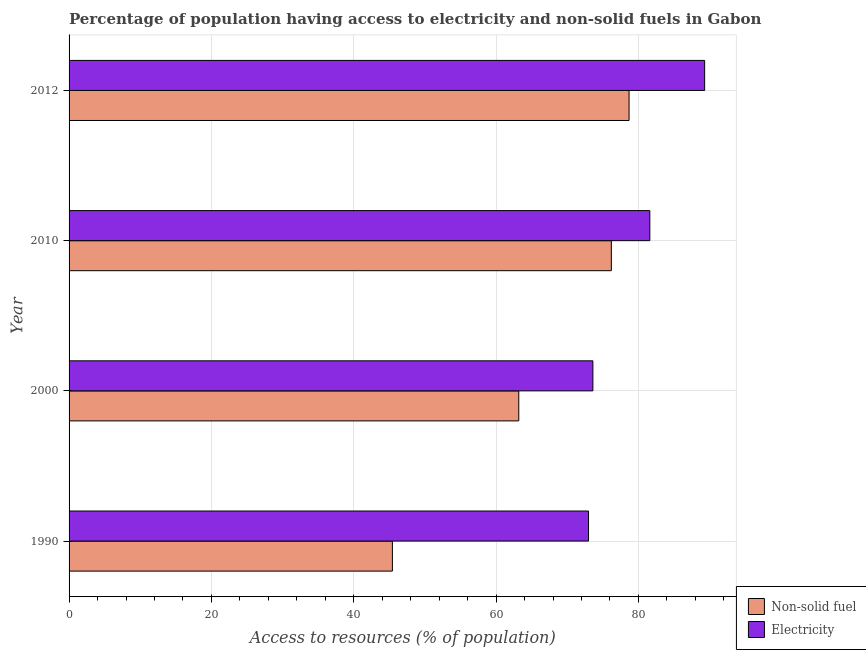How many different coloured bars are there?
Keep it short and to the point. 2. Are the number of bars per tick equal to the number of legend labels?
Give a very brief answer. Yes. Are the number of bars on each tick of the Y-axis equal?
Offer a very short reply. Yes. How many bars are there on the 1st tick from the top?
Offer a terse response. 2. In how many cases, is the number of bars for a given year not equal to the number of legend labels?
Your answer should be very brief. 0. What is the percentage of population having access to non-solid fuel in 2000?
Your answer should be very brief. 63.19. Across all years, what is the maximum percentage of population having access to electricity?
Make the answer very short. 89.3. Across all years, what is the minimum percentage of population having access to non-solid fuel?
Your answer should be compact. 45.43. In which year was the percentage of population having access to electricity minimum?
Your response must be concise. 1990. What is the total percentage of population having access to non-solid fuel in the graph?
Your answer should be very brief. 263.49. What is the difference between the percentage of population having access to non-solid fuel in 1990 and that in 2010?
Provide a succinct answer. -30.76. What is the difference between the percentage of population having access to non-solid fuel in 2000 and the percentage of population having access to electricity in 1990?
Keep it short and to the point. -9.8. What is the average percentage of population having access to electricity per year?
Provide a short and direct response. 79.37. In the year 2000, what is the difference between the percentage of population having access to non-solid fuel and percentage of population having access to electricity?
Ensure brevity in your answer.  -10.41. In how many years, is the percentage of population having access to electricity greater than 16 %?
Your answer should be very brief. 4. What is the ratio of the percentage of population having access to electricity in 1990 to that in 2000?
Offer a terse response. 0.99. Is the difference between the percentage of population having access to electricity in 2010 and 2012 greater than the difference between the percentage of population having access to non-solid fuel in 2010 and 2012?
Your response must be concise. No. What is the difference between the highest and the second highest percentage of population having access to electricity?
Provide a succinct answer. 7.7. What is the difference between the highest and the lowest percentage of population having access to electricity?
Offer a very short reply. 16.31. In how many years, is the percentage of population having access to electricity greater than the average percentage of population having access to electricity taken over all years?
Offer a very short reply. 2. What does the 2nd bar from the top in 2010 represents?
Your response must be concise. Non-solid fuel. What does the 2nd bar from the bottom in 2000 represents?
Provide a short and direct response. Electricity. Are all the bars in the graph horizontal?
Make the answer very short. Yes. How many years are there in the graph?
Offer a terse response. 4. What is the difference between two consecutive major ticks on the X-axis?
Keep it short and to the point. 20. Does the graph contain any zero values?
Your answer should be very brief. No. Does the graph contain grids?
Ensure brevity in your answer.  Yes. What is the title of the graph?
Make the answer very short. Percentage of population having access to electricity and non-solid fuels in Gabon. What is the label or title of the X-axis?
Provide a succinct answer. Access to resources (% of population). What is the label or title of the Y-axis?
Offer a terse response. Year. What is the Access to resources (% of population) of Non-solid fuel in 1990?
Keep it short and to the point. 45.43. What is the Access to resources (% of population) in Electricity in 1990?
Provide a succinct answer. 72.99. What is the Access to resources (% of population) of Non-solid fuel in 2000?
Provide a succinct answer. 63.19. What is the Access to resources (% of population) in Electricity in 2000?
Ensure brevity in your answer.  73.6. What is the Access to resources (% of population) of Non-solid fuel in 2010?
Offer a very short reply. 76.19. What is the Access to resources (% of population) of Electricity in 2010?
Give a very brief answer. 81.6. What is the Access to resources (% of population) in Non-solid fuel in 2012?
Provide a short and direct response. 78.68. What is the Access to resources (% of population) in Electricity in 2012?
Ensure brevity in your answer.  89.3. Across all years, what is the maximum Access to resources (% of population) in Non-solid fuel?
Your answer should be compact. 78.68. Across all years, what is the maximum Access to resources (% of population) in Electricity?
Give a very brief answer. 89.3. Across all years, what is the minimum Access to resources (% of population) of Non-solid fuel?
Provide a succinct answer. 45.43. Across all years, what is the minimum Access to resources (% of population) of Electricity?
Offer a very short reply. 72.99. What is the total Access to resources (% of population) of Non-solid fuel in the graph?
Offer a very short reply. 263.49. What is the total Access to resources (% of population) in Electricity in the graph?
Your response must be concise. 317.49. What is the difference between the Access to resources (% of population) in Non-solid fuel in 1990 and that in 2000?
Your answer should be compact. -17.76. What is the difference between the Access to resources (% of population) of Electricity in 1990 and that in 2000?
Give a very brief answer. -0.61. What is the difference between the Access to resources (% of population) of Non-solid fuel in 1990 and that in 2010?
Offer a very short reply. -30.76. What is the difference between the Access to resources (% of population) in Electricity in 1990 and that in 2010?
Offer a very short reply. -8.61. What is the difference between the Access to resources (% of population) in Non-solid fuel in 1990 and that in 2012?
Offer a very short reply. -33.25. What is the difference between the Access to resources (% of population) of Electricity in 1990 and that in 2012?
Keep it short and to the point. -16.31. What is the difference between the Access to resources (% of population) in Non-solid fuel in 2000 and that in 2010?
Provide a short and direct response. -13.01. What is the difference between the Access to resources (% of population) of Non-solid fuel in 2000 and that in 2012?
Give a very brief answer. -15.49. What is the difference between the Access to resources (% of population) of Electricity in 2000 and that in 2012?
Ensure brevity in your answer.  -15.7. What is the difference between the Access to resources (% of population) of Non-solid fuel in 2010 and that in 2012?
Provide a succinct answer. -2.49. What is the difference between the Access to resources (% of population) in Electricity in 2010 and that in 2012?
Make the answer very short. -7.7. What is the difference between the Access to resources (% of population) of Non-solid fuel in 1990 and the Access to resources (% of population) of Electricity in 2000?
Ensure brevity in your answer.  -28.17. What is the difference between the Access to resources (% of population) in Non-solid fuel in 1990 and the Access to resources (% of population) in Electricity in 2010?
Your response must be concise. -36.17. What is the difference between the Access to resources (% of population) of Non-solid fuel in 1990 and the Access to resources (% of population) of Electricity in 2012?
Ensure brevity in your answer.  -43.87. What is the difference between the Access to resources (% of population) of Non-solid fuel in 2000 and the Access to resources (% of population) of Electricity in 2010?
Your answer should be very brief. -18.41. What is the difference between the Access to resources (% of population) in Non-solid fuel in 2000 and the Access to resources (% of population) in Electricity in 2012?
Your answer should be compact. -26.11. What is the difference between the Access to resources (% of population) of Non-solid fuel in 2010 and the Access to resources (% of population) of Electricity in 2012?
Your answer should be compact. -13.11. What is the average Access to resources (% of population) in Non-solid fuel per year?
Provide a short and direct response. 65.87. What is the average Access to resources (% of population) in Electricity per year?
Your answer should be compact. 79.37. In the year 1990, what is the difference between the Access to resources (% of population) of Non-solid fuel and Access to resources (% of population) of Electricity?
Your response must be concise. -27.56. In the year 2000, what is the difference between the Access to resources (% of population) in Non-solid fuel and Access to resources (% of population) in Electricity?
Offer a very short reply. -10.41. In the year 2010, what is the difference between the Access to resources (% of population) of Non-solid fuel and Access to resources (% of population) of Electricity?
Ensure brevity in your answer.  -5.41. In the year 2012, what is the difference between the Access to resources (% of population) in Non-solid fuel and Access to resources (% of population) in Electricity?
Your answer should be compact. -10.62. What is the ratio of the Access to resources (% of population) in Non-solid fuel in 1990 to that in 2000?
Give a very brief answer. 0.72. What is the ratio of the Access to resources (% of population) of Non-solid fuel in 1990 to that in 2010?
Your response must be concise. 0.6. What is the ratio of the Access to resources (% of population) of Electricity in 1990 to that in 2010?
Make the answer very short. 0.89. What is the ratio of the Access to resources (% of population) in Non-solid fuel in 1990 to that in 2012?
Your answer should be compact. 0.58. What is the ratio of the Access to resources (% of population) of Electricity in 1990 to that in 2012?
Ensure brevity in your answer.  0.82. What is the ratio of the Access to resources (% of population) in Non-solid fuel in 2000 to that in 2010?
Offer a very short reply. 0.83. What is the ratio of the Access to resources (% of population) of Electricity in 2000 to that in 2010?
Your answer should be very brief. 0.9. What is the ratio of the Access to resources (% of population) of Non-solid fuel in 2000 to that in 2012?
Give a very brief answer. 0.8. What is the ratio of the Access to resources (% of population) of Electricity in 2000 to that in 2012?
Make the answer very short. 0.82. What is the ratio of the Access to resources (% of population) of Non-solid fuel in 2010 to that in 2012?
Provide a succinct answer. 0.97. What is the ratio of the Access to resources (% of population) of Electricity in 2010 to that in 2012?
Provide a succinct answer. 0.91. What is the difference between the highest and the second highest Access to resources (% of population) in Non-solid fuel?
Offer a very short reply. 2.49. What is the difference between the highest and the lowest Access to resources (% of population) in Non-solid fuel?
Your answer should be very brief. 33.25. What is the difference between the highest and the lowest Access to resources (% of population) of Electricity?
Ensure brevity in your answer.  16.31. 